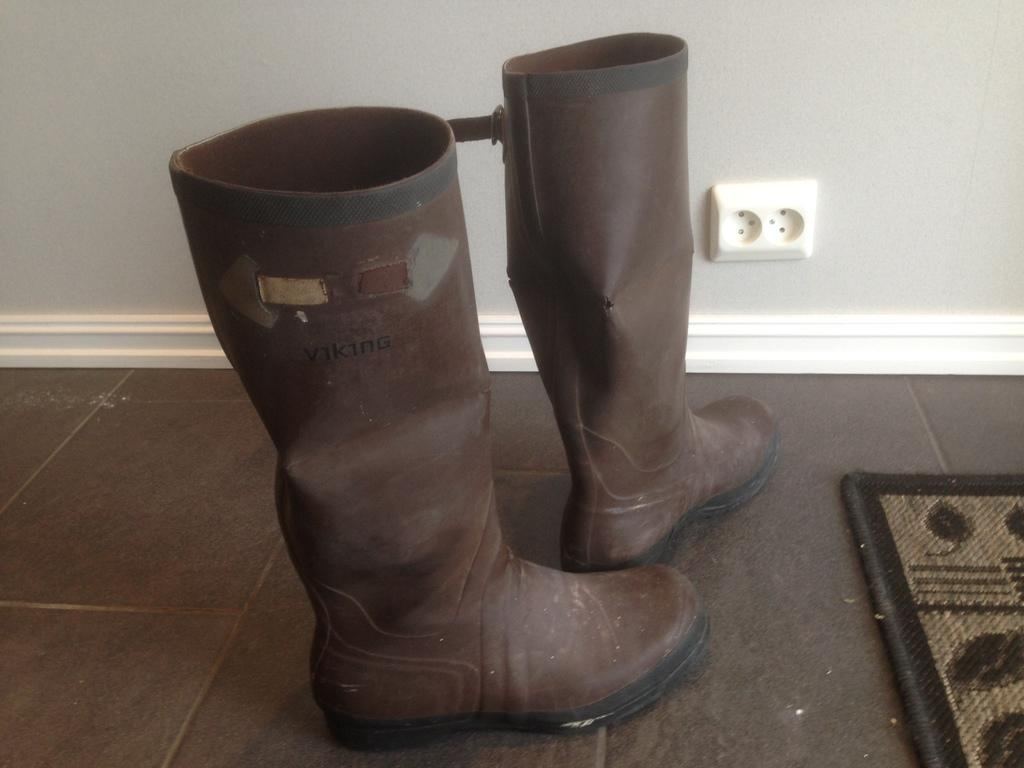What type of footwear is present in the image? There are riding boots in the image. What color are the riding boots? The riding boots are brown in color. What can be seen in the background of the image? There is a wall visible in the image. What type of nation is being discussed in the image? There is no discussion or nation mentioned in the image; it only features riding boots and a wall. 